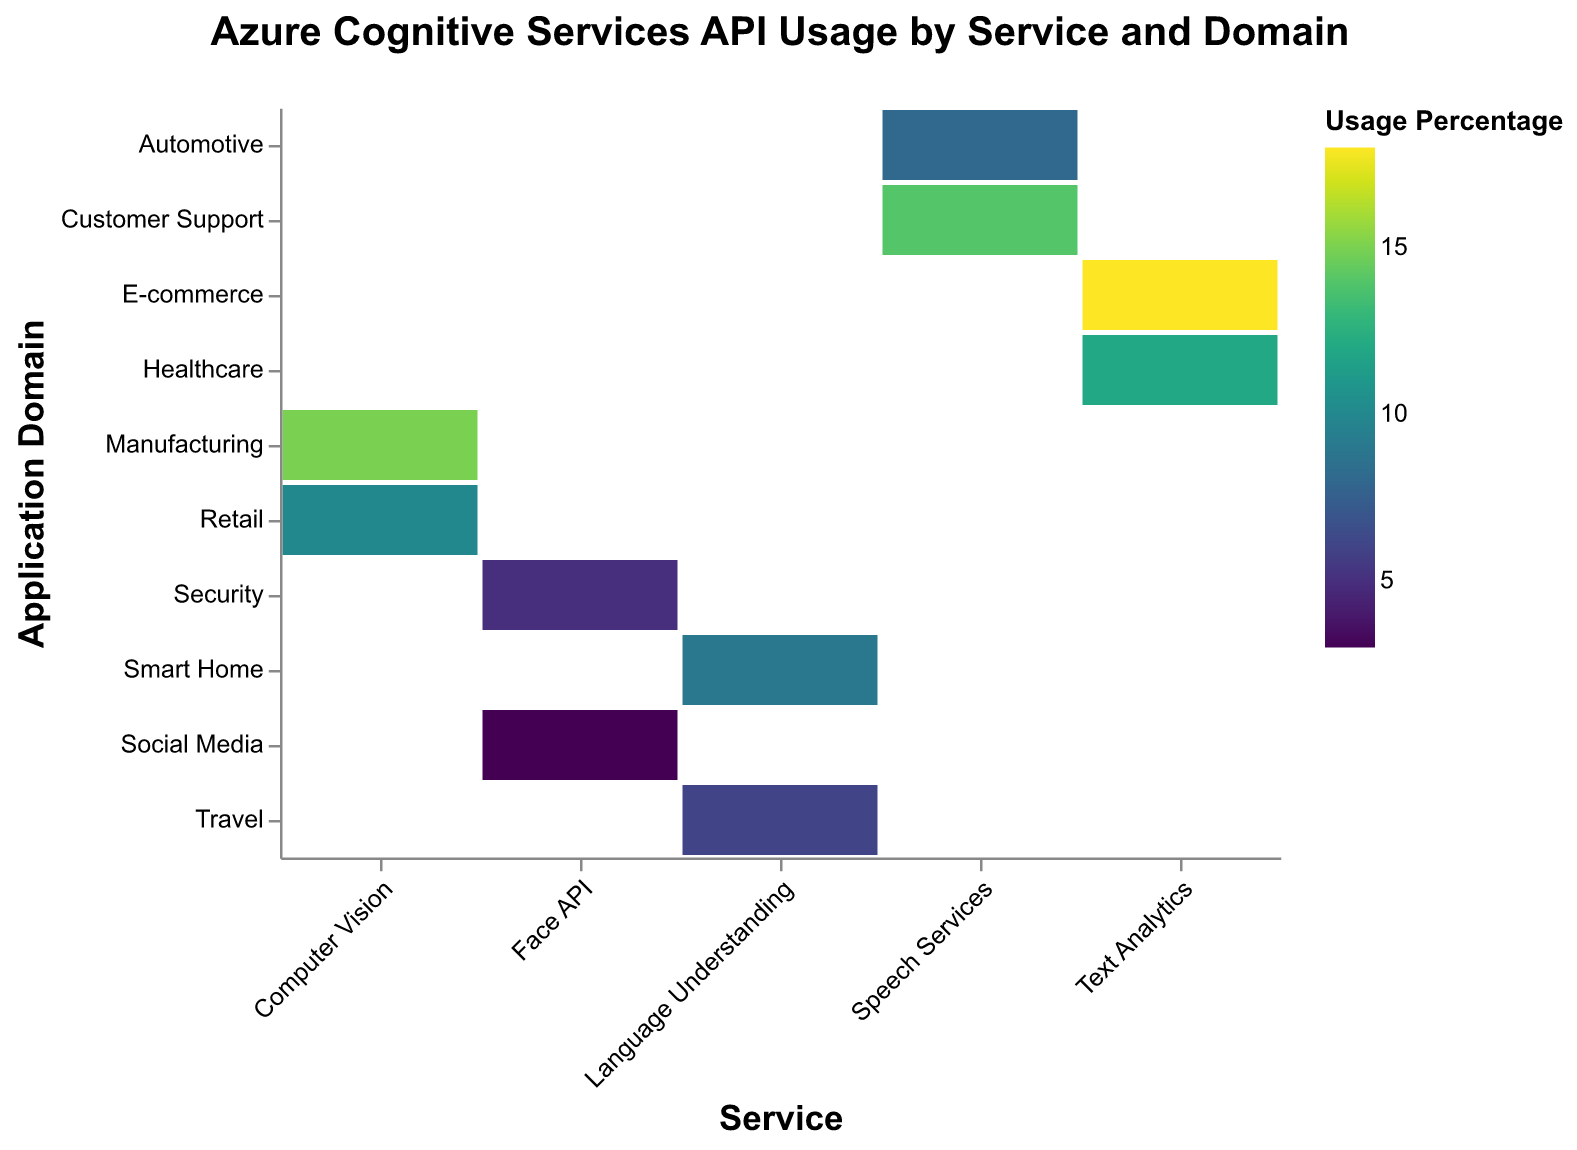Which service has the highest usage percentage in E-commerce? Locate the cell corresponding to the "Text Analytics" service and the "E-commerce" application domain. The Usage Percentage is displayed there.
Answer: Text Analytics How many application domains use the Speech Services API? The "Speech Services" API can be seen to intersect with two different application domains: "Customer Support" and "Automotive."
Answer: 2 What is the total usage percentage for Computer Vision across all application domains? Sum the Usage Percentages for Computer Vision in both "Manufacturing" and "Retail" application domains: 15 + 10.
Answer: 25 Which has a higher usage percentage in Healthcare: Text Analytics or Face API? Compare the Usage Percentage values in Healthcare for Text Analytics and Face API. "Healthcare" only intersects with "Text Analytics," not Face API.
Answer: Text Analytics What is the average usage percentage of Language Understanding services across its application domains? The Usage Percentages for Language Understanding in "Smart Home" and "Travel" are 9 and 6, respectively. The average would be (9 + 6)/2.
Answer: 7.5 Which service has the lowest usage in any application domain? Identify the smallest usage percentage in the entire plot. The value "3" is the smallest for "Face API" in "Social Media."
Answer: Face API in Social Media How do the usage percentages of Speech Services compare between Customer Support and Automotive? Locate the cells for both application domains under Speech Services and compare their Usage Percentages. "Customer Support" is 14 and "Automotive" is 8, so Customer Support is higher.
Answer: Customer Support is higher What is the difference in usage percentage between Text Analytics in E-commerce and Computer Vision in Retail? Subtract the Usage Percentage of Computer Vision in Retail from that of Text Analytics in E-commerce: 18 - 10.
Answer: 8 What application domain does Computer Vision have the highest usage percentage in? Compare the Usage Percentages of Computer Vision in Manufacturing and Retail. The higher value is in Manufacturing.
Answer: Manufacturing Does Language Understanding have a higher or lower average usage percentage than Speech Services? Calculate the average usage percentage for Language Understanding (7.5) and compare it with the average for Speech Services ((14 + 8)/2 = 11).
Answer: Lower 